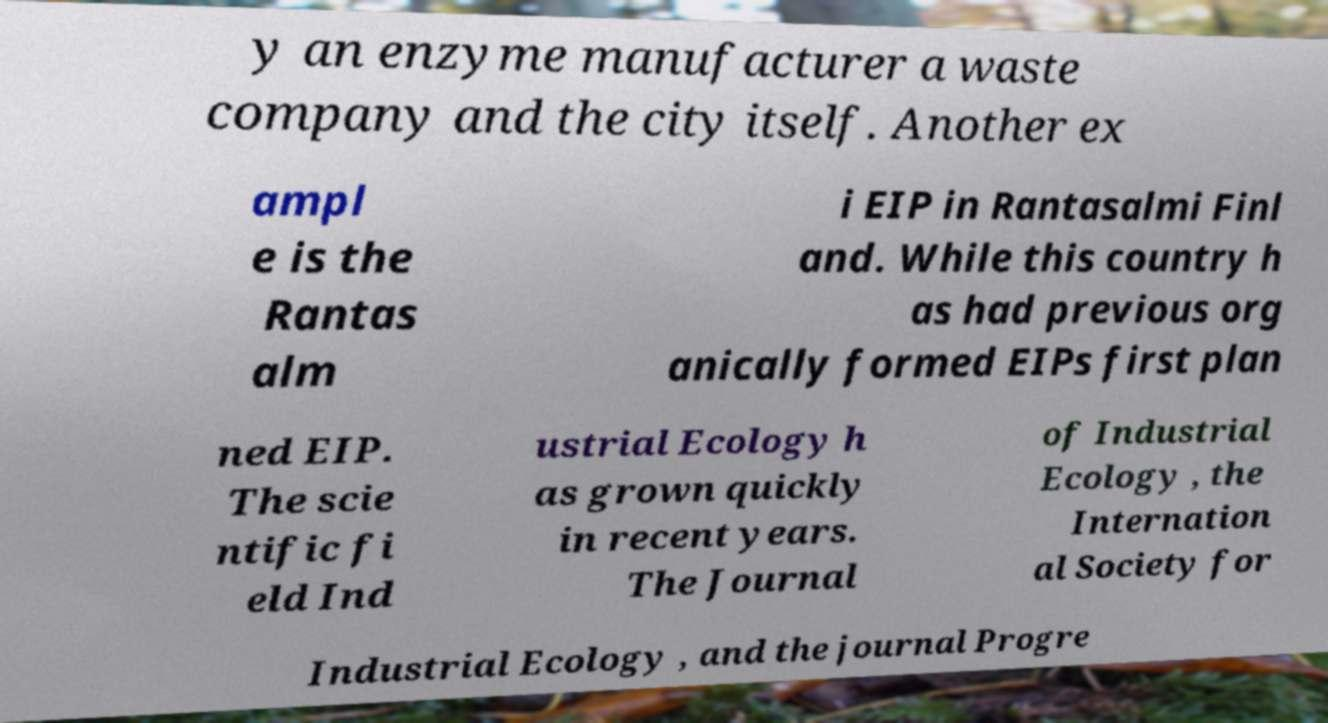Can you accurately transcribe the text from the provided image for me? y an enzyme manufacturer a waste company and the city itself. Another ex ampl e is the Rantas alm i EIP in Rantasalmi Finl and. While this country h as had previous org anically formed EIPs first plan ned EIP. The scie ntific fi eld Ind ustrial Ecology h as grown quickly in recent years. The Journal of Industrial Ecology , the Internation al Society for Industrial Ecology , and the journal Progre 